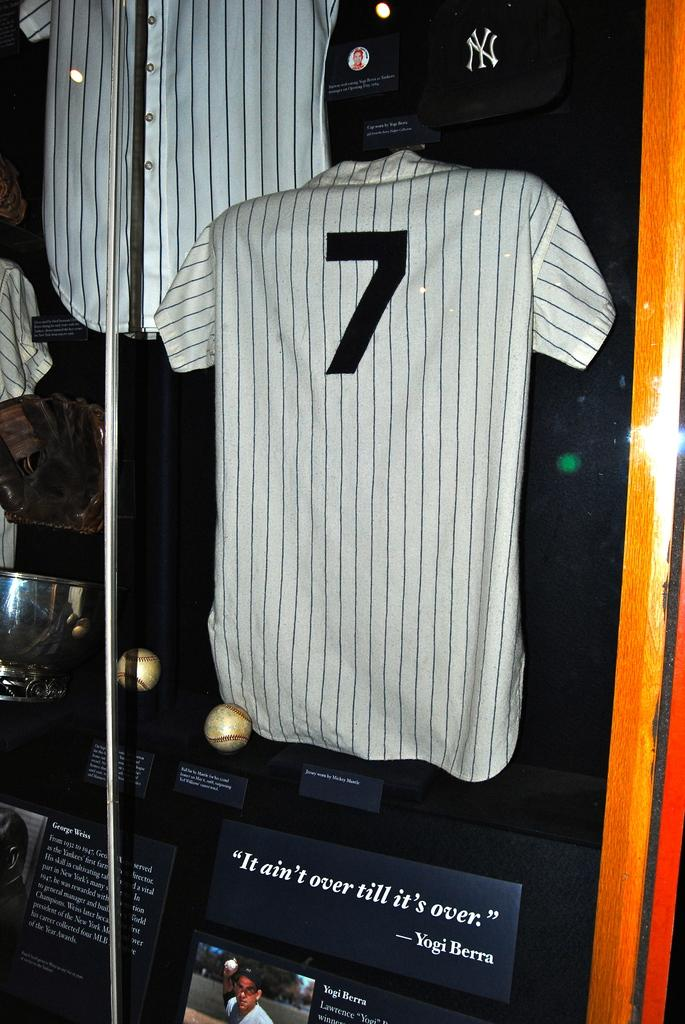<image>
Render a clear and concise summary of the photo. A striped baseball shirt with the number 7 on the back inside a case. 